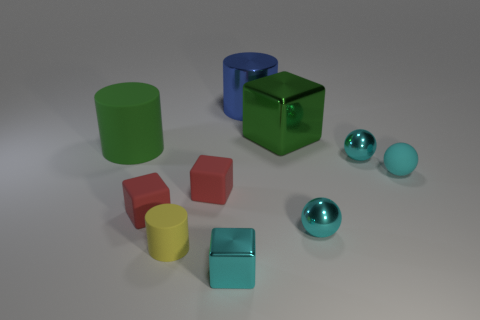How many cyan balls must be subtracted to get 1 cyan balls? 2 Subtract all cylinders. How many objects are left? 7 Subtract 0 cyan cylinders. How many objects are left? 10 Subtract all metal things. Subtract all small red cylinders. How many objects are left? 5 Add 1 big blue objects. How many big blue objects are left? 2 Add 3 cyan cubes. How many cyan cubes exist? 4 